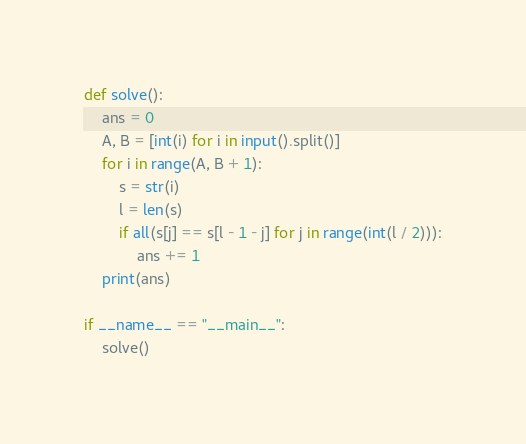<code> <loc_0><loc_0><loc_500><loc_500><_Python_>def solve():
    ans = 0
    A, B = [int(i) for i in input().split()]
    for i in range(A, B + 1):
        s = str(i)
        l = len(s)
        if all(s[j] == s[l - 1 - j] for j in range(int(l / 2))):
            ans += 1
    print(ans)

if __name__ == "__main__":
    solve()</code> 